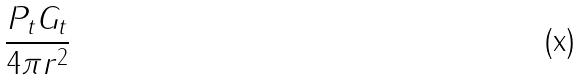<formula> <loc_0><loc_0><loc_500><loc_500>\frac { P _ { t } G _ { t } } { 4 \pi r ^ { 2 } }</formula> 